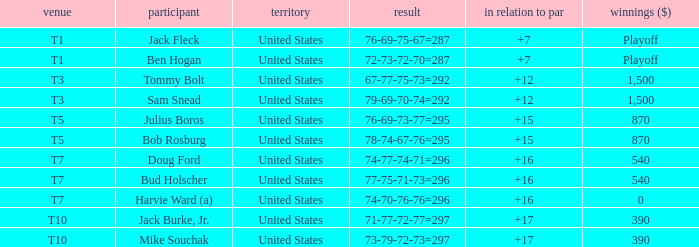Parse the full table. {'header': ['venue', 'participant', 'territory', 'result', 'in relation to par', 'winnings ($)'], 'rows': [['T1', 'Jack Fleck', 'United States', '76-69-75-67=287', '+7', 'Playoff'], ['T1', 'Ben Hogan', 'United States', '72-73-72-70=287', '+7', 'Playoff'], ['T3', 'Tommy Bolt', 'United States', '67-77-75-73=292', '+12', '1,500'], ['T3', 'Sam Snead', 'United States', '79-69-70-74=292', '+12', '1,500'], ['T5', 'Julius Boros', 'United States', '76-69-73-77=295', '+15', '870'], ['T5', 'Bob Rosburg', 'United States', '78-74-67-76=295', '+15', '870'], ['T7', 'Doug Ford', 'United States', '74-77-74-71=296', '+16', '540'], ['T7', 'Bud Holscher', 'United States', '77-75-71-73=296', '+16', '540'], ['T7', 'Harvie Ward (a)', 'United States', '74-70-76-76=296', '+16', '0'], ['T10', 'Jack Burke, Jr.', 'United States', '71-77-72-77=297', '+17', '390'], ['T10', 'Mike Souchak', 'United States', '73-79-72-73=297', '+17', '390']]} What is the total of all to par with player Bob Rosburg? 15.0. 